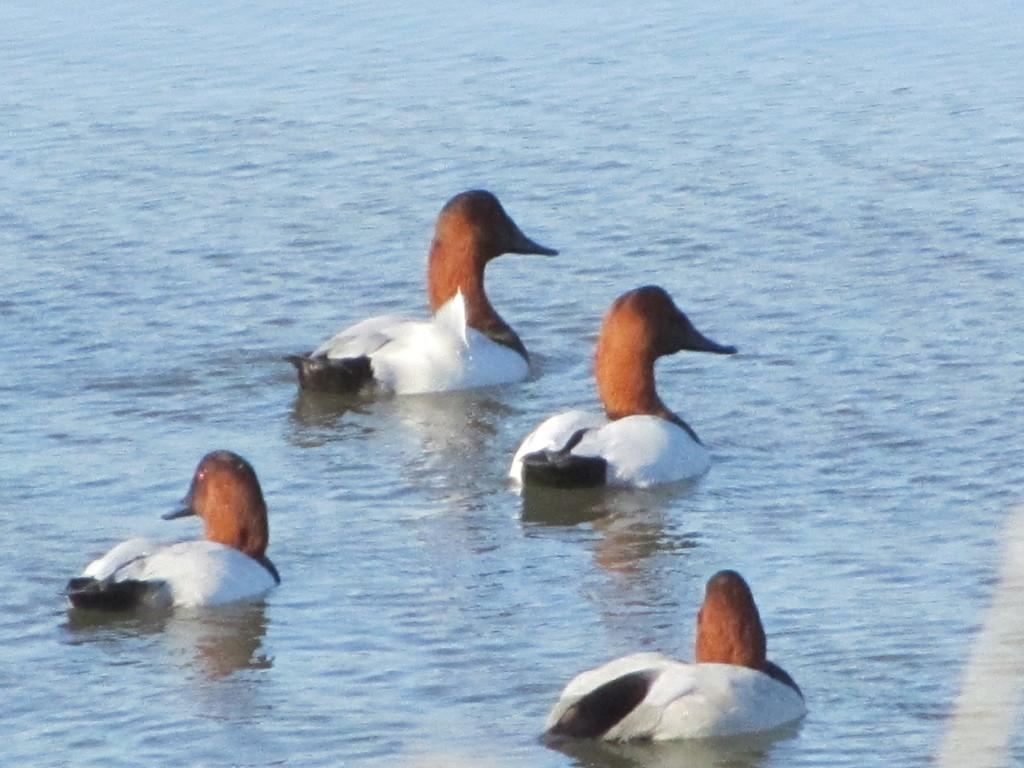How many ducks are present in the image? There are four ducks in the image. Where are the ducks located? The ducks are in the water. What is the color of the water in the image? The water is blue in color. How many girls are present in the image? There are no girls present in the image; it features four ducks in the water. What memory does the image evoke for you? The image does not evoke any specific memory, as it is a simple depiction of four ducks in the water. 